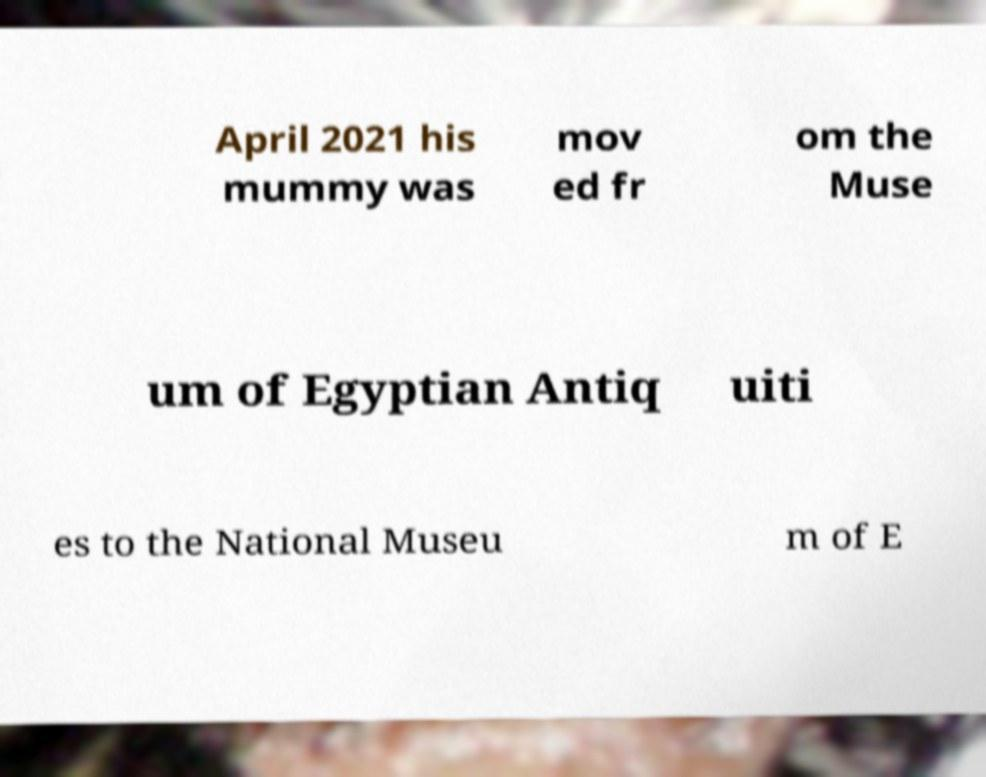For documentation purposes, I need the text within this image transcribed. Could you provide that? April 2021 his mummy was mov ed fr om the Muse um of Egyptian Antiq uiti es to the National Museu m of E 